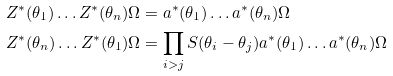<formula> <loc_0><loc_0><loc_500><loc_500>Z ^ { \ast } ( \theta _ { 1 } ) \dots Z ^ { \ast } ( \theta _ { n } ) \Omega & = a ^ { \ast } ( \theta _ { 1 } ) \dots a ^ { \ast } ( \theta _ { n } ) \Omega \\ Z ^ { \ast } ( \theta _ { n } ) \dots Z ^ { \ast } ( \theta _ { 1 } ) \Omega & = \prod _ { i > j } S ( \theta _ { i } - \theta _ { j } ) a ^ { \ast } ( \theta _ { 1 } ) \dots a ^ { \ast } ( \theta _ { n } ) \Omega</formula> 